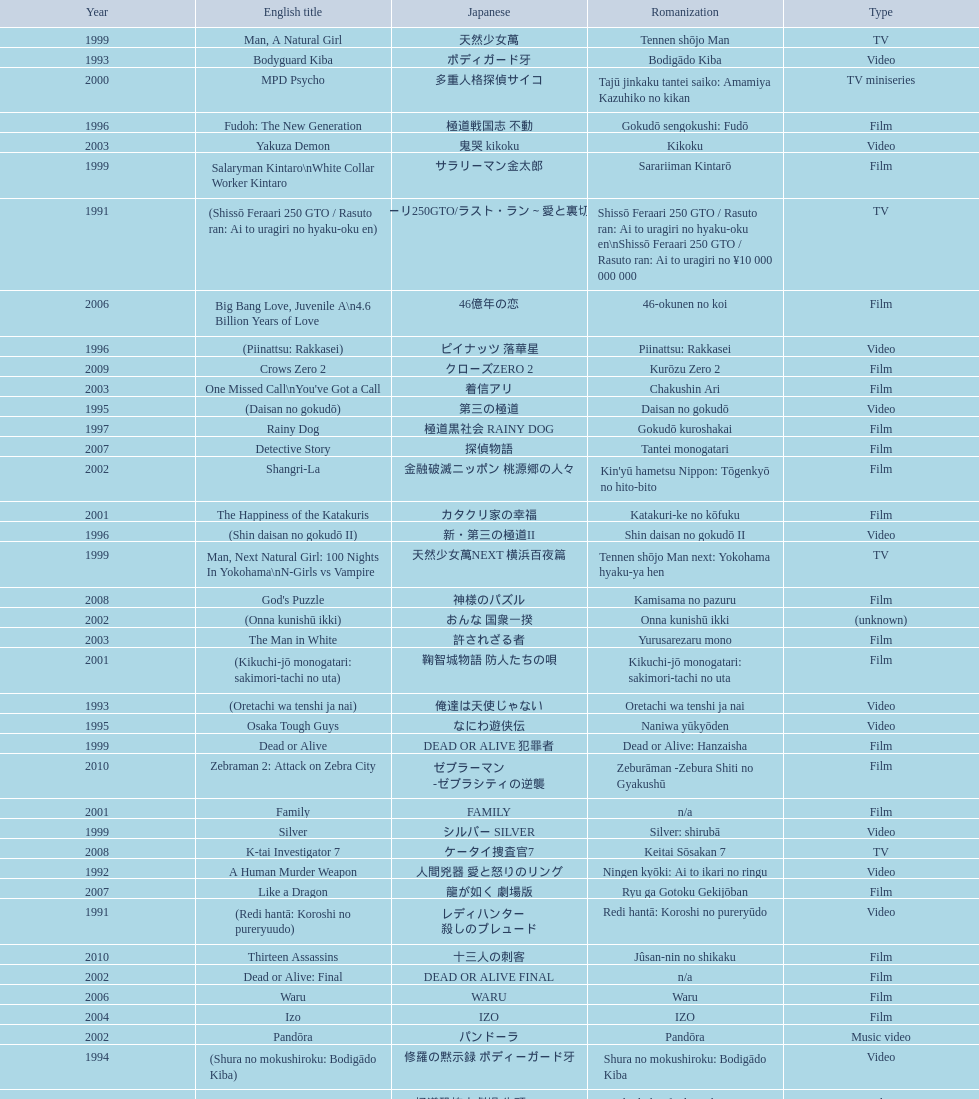Was shinjuku triad society a film or tv release? Film. 